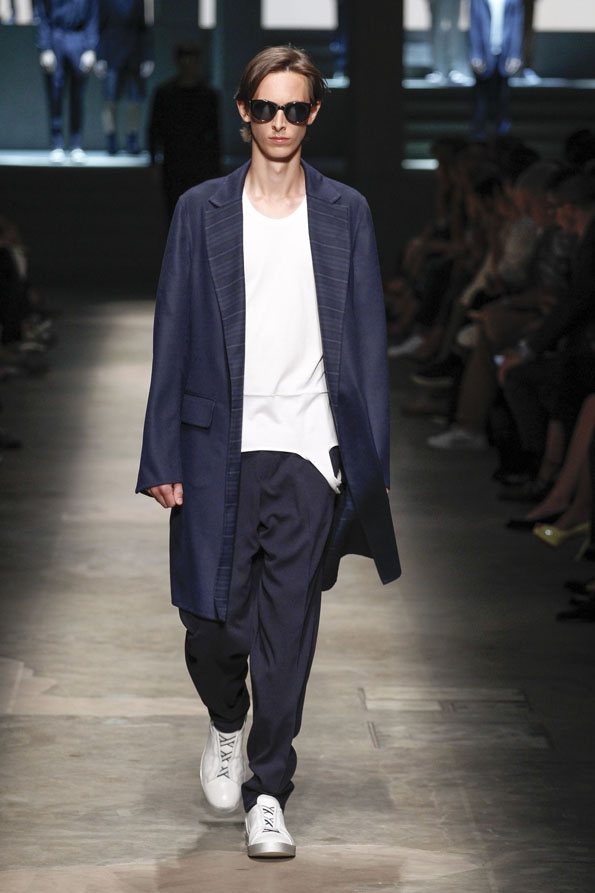Based on the attire and accessories chosen for the model, what might be the intended message or theme the designer is trying to convey through this particular outfit in the context of a fashion show? The ensemble depicted in the image conveys a theme of 'relaxed sophistication.' The oversized navy blue coat, paired with a minimalist white t-shirt and loose trousers, epitomizes a balance between elegance and comfort. This combination indicates the designer's intent to merge formal and casual styles seamlessly, making fashion accessible yet stylish. The prominence of navy blue lends a timeless, classic appeal, while the white sneakers introduce a contemporary, youthful vibe, symbolizing versatility in modern fashion. The addition of dark sunglasses amplifies the chic, mysterious aura of the outfit. Consequently, the designer is likely targeting a younger, fashion-forward audience who values practical yet polished aesthetics. 